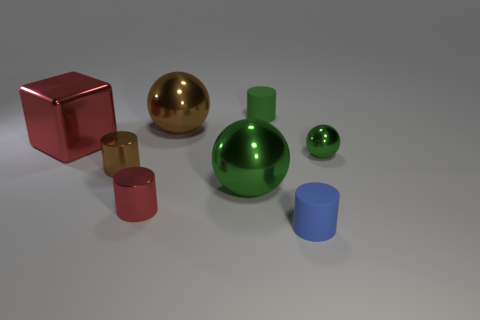There is a rubber cylinder that is the same color as the small metallic ball; what size is it?
Give a very brief answer. Small. Is the size of the green cylinder the same as the green ball in front of the small green shiny thing?
Provide a succinct answer. No. Are there fewer green balls to the right of the large green metallic thing than tiny brown cylinders?
Keep it short and to the point. No. There is a blue object that is the same shape as the tiny red metallic object; what is its material?
Provide a short and direct response. Rubber. There is a small object that is in front of the big green metal thing and on the right side of the small red cylinder; what is its shape?
Provide a succinct answer. Cylinder. There is a tiny brown object that is the same material as the big red block; what shape is it?
Your answer should be compact. Cylinder. There is a small green thing to the right of the small blue matte cylinder; what is it made of?
Your answer should be compact. Metal. Is the size of the red thing behind the tiny red object the same as the cylinder on the right side of the tiny green rubber thing?
Keep it short and to the point. No. The tiny ball has what color?
Offer a very short reply. Green. Do the matte thing behind the large brown ball and the big green thing have the same shape?
Provide a short and direct response. No. 